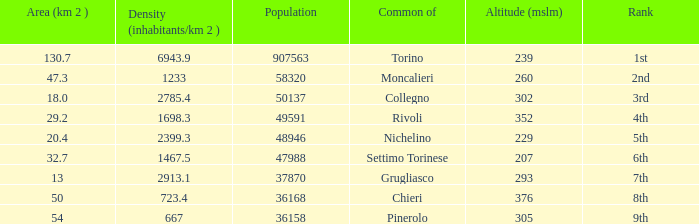How many altitudes does the common with an area of 130.7 km^2 have? 1.0. 